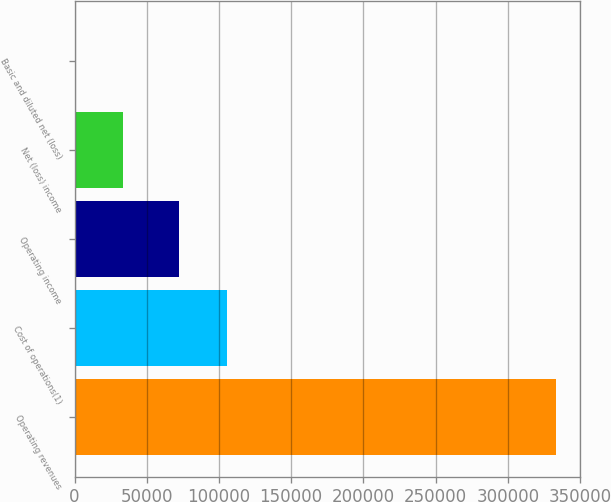<chart> <loc_0><loc_0><loc_500><loc_500><bar_chart><fcel>Operating revenues<fcel>Cost of operations(1)<fcel>Operating income<fcel>Net (loss) income<fcel>Basic and diluted net (loss)<nl><fcel>333467<fcel>105354<fcel>72007<fcel>33346.7<fcel>0.01<nl></chart> 